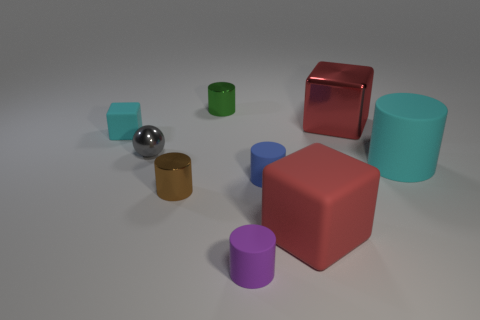Could you create a story involving these objects? Once upon a time in a calm, serene space, the Colorful Kingdom of Shapes was in a bit of a stir. The Sphere, with its shiny armor, had called for a meeting to discuss the sudden disappearance of light in certain corners of their realm. The noble Cubes, the wise Cylinders, and the stout Wooden Barrel gathered around in solidarity. They embarked on a quest to uncover the source of shadow and light, learning along the way the importance of their unique traits: The Sphere's reflective wisdom, the Cubes' grounded stability, and the Cylinders' well-rounded perspectives. Together, they restored harmony, ensuring that every corner of the kingdom glowed with enlightenment. 